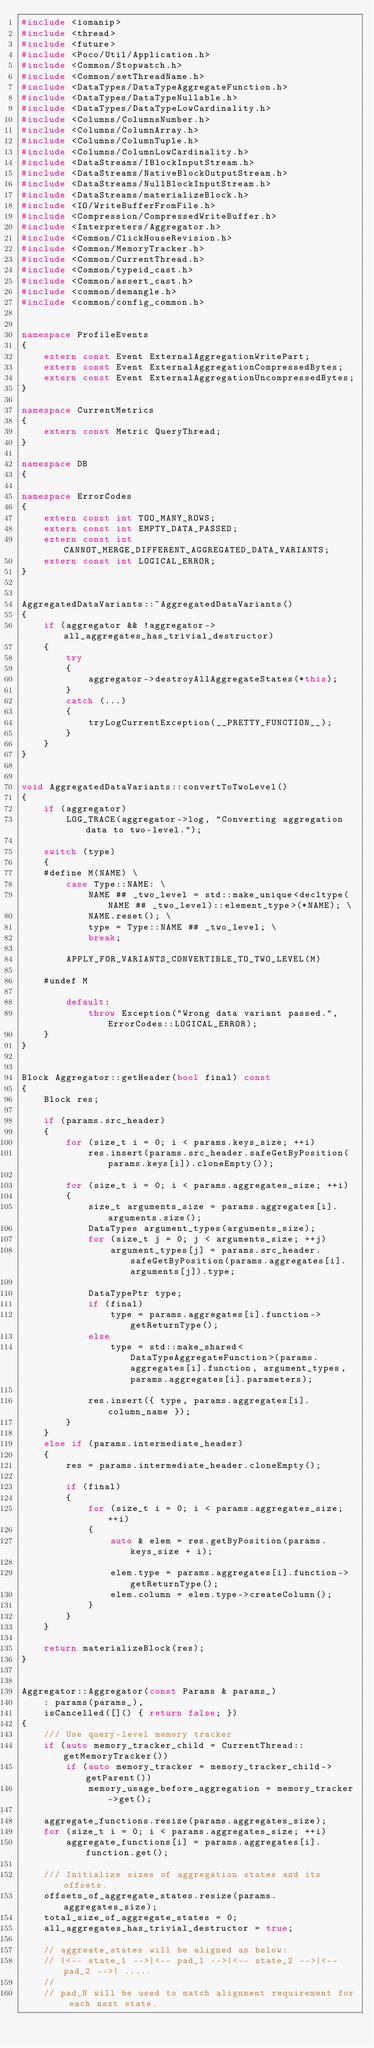<code> <loc_0><loc_0><loc_500><loc_500><_C++_>#include <iomanip>
#include <thread>
#include <future>
#include <Poco/Util/Application.h>
#include <Common/Stopwatch.h>
#include <Common/setThreadName.h>
#include <DataTypes/DataTypeAggregateFunction.h>
#include <DataTypes/DataTypeNullable.h>
#include <DataTypes/DataTypeLowCardinality.h>
#include <Columns/ColumnsNumber.h>
#include <Columns/ColumnArray.h>
#include <Columns/ColumnTuple.h>
#include <Columns/ColumnLowCardinality.h>
#include <DataStreams/IBlockInputStream.h>
#include <DataStreams/NativeBlockOutputStream.h>
#include <DataStreams/NullBlockInputStream.h>
#include <DataStreams/materializeBlock.h>
#include <IO/WriteBufferFromFile.h>
#include <Compression/CompressedWriteBuffer.h>
#include <Interpreters/Aggregator.h>
#include <Common/ClickHouseRevision.h>
#include <Common/MemoryTracker.h>
#include <Common/CurrentThread.h>
#include <Common/typeid_cast.h>
#include <Common/assert_cast.h>
#include <common/demangle.h>
#include <common/config_common.h>


namespace ProfileEvents
{
    extern const Event ExternalAggregationWritePart;
    extern const Event ExternalAggregationCompressedBytes;
    extern const Event ExternalAggregationUncompressedBytes;
}

namespace CurrentMetrics
{
    extern const Metric QueryThread;
}

namespace DB
{

namespace ErrorCodes
{
    extern const int TOO_MANY_ROWS;
    extern const int EMPTY_DATA_PASSED;
    extern const int CANNOT_MERGE_DIFFERENT_AGGREGATED_DATA_VARIANTS;
    extern const int LOGICAL_ERROR;
}


AggregatedDataVariants::~AggregatedDataVariants()
{
    if (aggregator && !aggregator->all_aggregates_has_trivial_destructor)
    {
        try
        {
            aggregator->destroyAllAggregateStates(*this);
        }
        catch (...)
        {
            tryLogCurrentException(__PRETTY_FUNCTION__);
        }
    }
}


void AggregatedDataVariants::convertToTwoLevel()
{
    if (aggregator)
        LOG_TRACE(aggregator->log, "Converting aggregation data to two-level.");

    switch (type)
    {
    #define M(NAME) \
        case Type::NAME: \
            NAME ## _two_level = std::make_unique<decltype(NAME ## _two_level)::element_type>(*NAME); \
            NAME.reset(); \
            type = Type::NAME ## _two_level; \
            break;

        APPLY_FOR_VARIANTS_CONVERTIBLE_TO_TWO_LEVEL(M)

    #undef M

        default:
            throw Exception("Wrong data variant passed.", ErrorCodes::LOGICAL_ERROR);
    }
}


Block Aggregator::getHeader(bool final) const
{
    Block res;

    if (params.src_header)
    {
        for (size_t i = 0; i < params.keys_size; ++i)
            res.insert(params.src_header.safeGetByPosition(params.keys[i]).cloneEmpty());

        for (size_t i = 0; i < params.aggregates_size; ++i)
        {
            size_t arguments_size = params.aggregates[i].arguments.size();
            DataTypes argument_types(arguments_size);
            for (size_t j = 0; j < arguments_size; ++j)
                argument_types[j] = params.src_header.safeGetByPosition(params.aggregates[i].arguments[j]).type;

            DataTypePtr type;
            if (final)
                type = params.aggregates[i].function->getReturnType();
            else
                type = std::make_shared<DataTypeAggregateFunction>(params.aggregates[i].function, argument_types, params.aggregates[i].parameters);

            res.insert({ type, params.aggregates[i].column_name });
        }
    }
    else if (params.intermediate_header)
    {
        res = params.intermediate_header.cloneEmpty();

        if (final)
        {
            for (size_t i = 0; i < params.aggregates_size; ++i)
            {
                auto & elem = res.getByPosition(params.keys_size + i);

                elem.type = params.aggregates[i].function->getReturnType();
                elem.column = elem.type->createColumn();
            }
        }
    }

    return materializeBlock(res);
}


Aggregator::Aggregator(const Params & params_)
    : params(params_),
    isCancelled([]() { return false; })
{
    /// Use query-level memory tracker
    if (auto memory_tracker_child = CurrentThread::getMemoryTracker())
        if (auto memory_tracker = memory_tracker_child->getParent())
            memory_usage_before_aggregation = memory_tracker->get();

    aggregate_functions.resize(params.aggregates_size);
    for (size_t i = 0; i < params.aggregates_size; ++i)
        aggregate_functions[i] = params.aggregates[i].function.get();

    /// Initialize sizes of aggregation states and its offsets.
    offsets_of_aggregate_states.resize(params.aggregates_size);
    total_size_of_aggregate_states = 0;
    all_aggregates_has_trivial_destructor = true;

    // aggreate_states will be aligned as below:
    // |<-- state_1 -->|<-- pad_1 -->|<-- state_2 -->|<-- pad_2 -->| .....
    //
    // pad_N will be used to match alignment requirement for each next state.</code> 